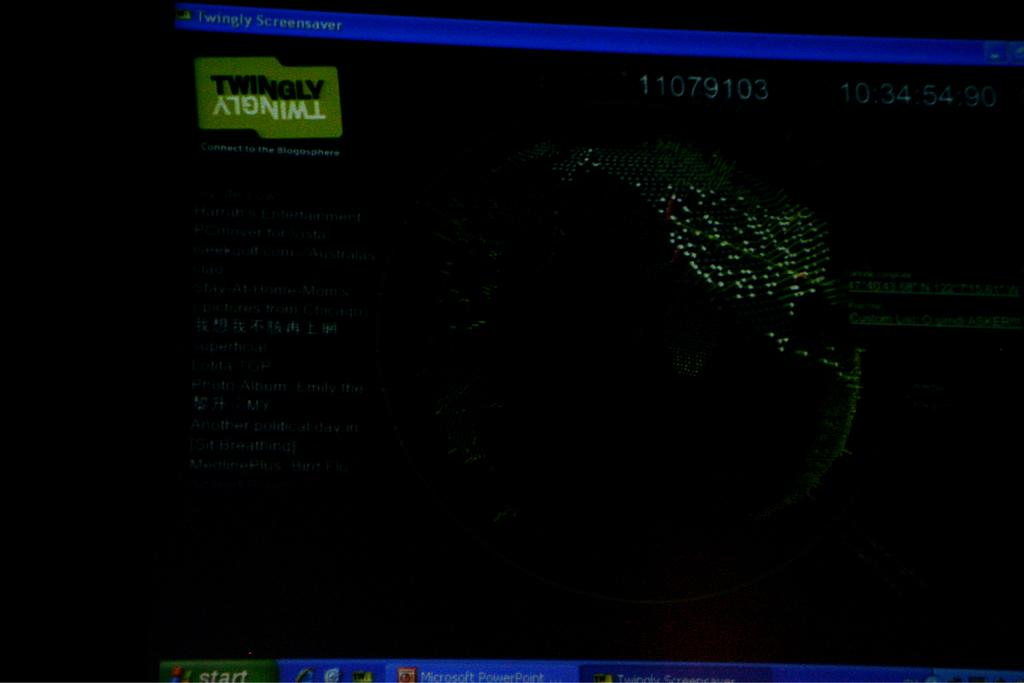<image>
Offer a succinct explanation of the picture presented. Dark and green screen that says Twingly on top. 